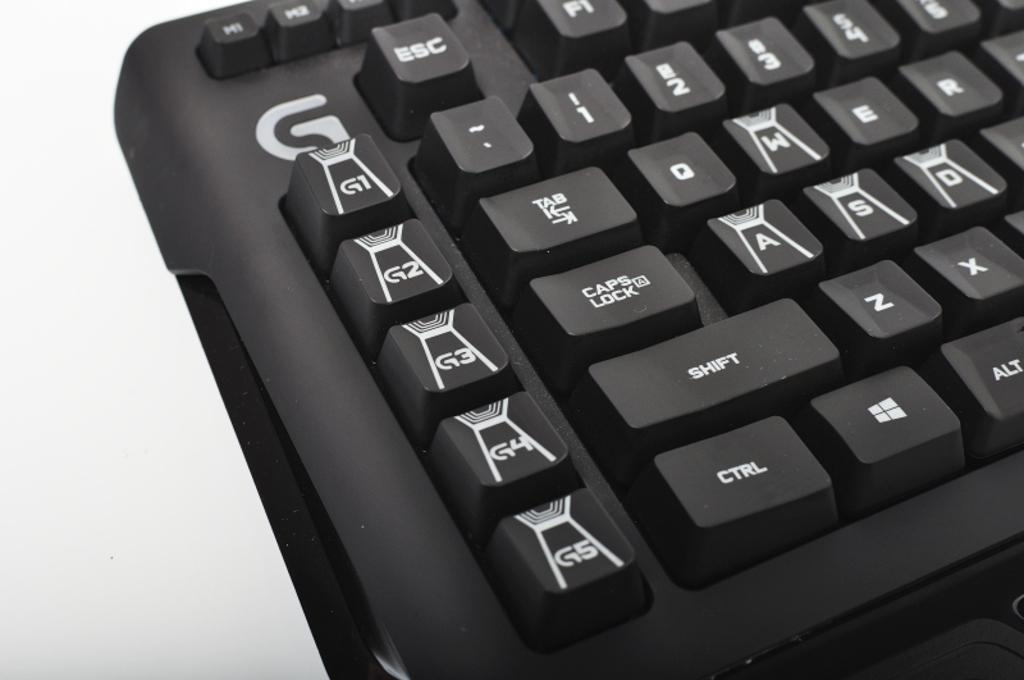<image>
Present a compact description of the photo's key features. Partial view of a black G keyboard with shift, CTRL and alt visible. 